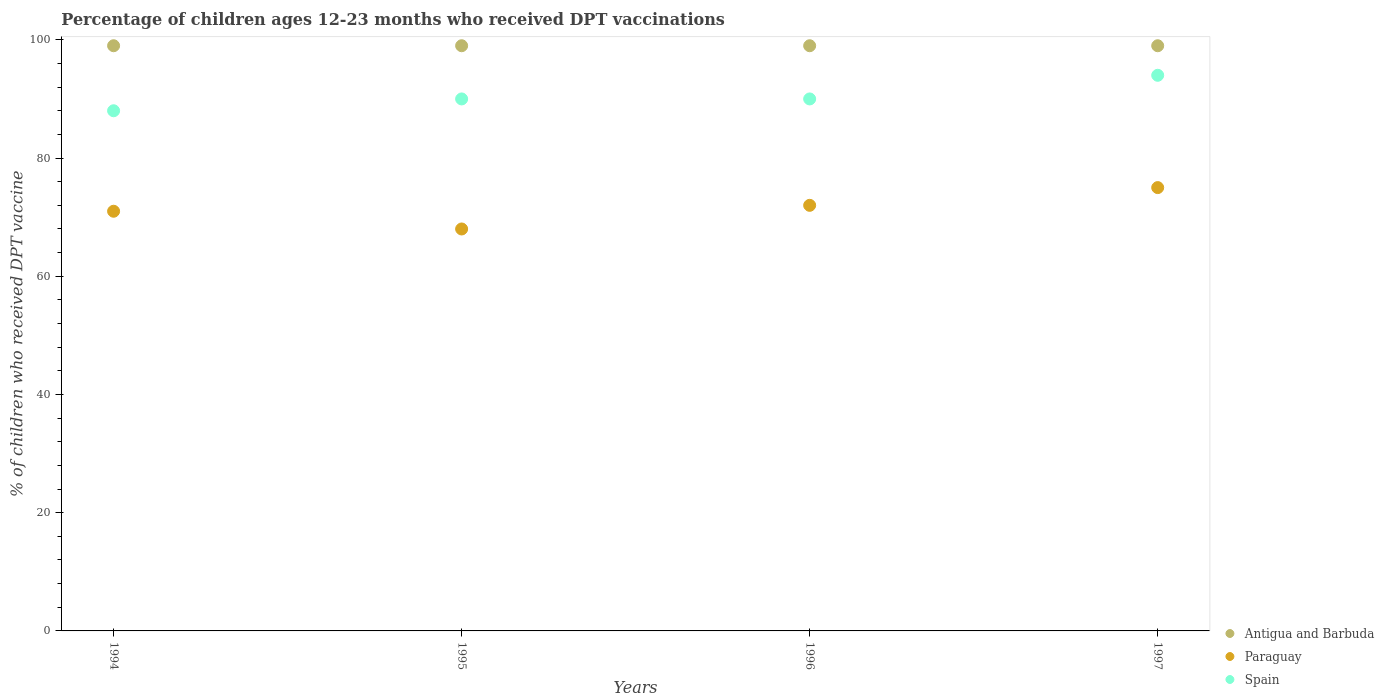How many different coloured dotlines are there?
Give a very brief answer. 3. What is the percentage of children who received DPT vaccination in Antigua and Barbuda in 1996?
Make the answer very short. 99. Across all years, what is the maximum percentage of children who received DPT vaccination in Antigua and Barbuda?
Make the answer very short. 99. Across all years, what is the minimum percentage of children who received DPT vaccination in Antigua and Barbuda?
Your response must be concise. 99. In which year was the percentage of children who received DPT vaccination in Antigua and Barbuda minimum?
Make the answer very short. 1994. What is the total percentage of children who received DPT vaccination in Antigua and Barbuda in the graph?
Your response must be concise. 396. What is the difference between the percentage of children who received DPT vaccination in Paraguay in 1994 and the percentage of children who received DPT vaccination in Antigua and Barbuda in 1996?
Your answer should be very brief. -28. What is the average percentage of children who received DPT vaccination in Antigua and Barbuda per year?
Offer a terse response. 99. In the year 1995, what is the difference between the percentage of children who received DPT vaccination in Antigua and Barbuda and percentage of children who received DPT vaccination in Paraguay?
Offer a very short reply. 31. What is the ratio of the percentage of children who received DPT vaccination in Spain in 1995 to that in 1996?
Give a very brief answer. 1. Is the difference between the percentage of children who received DPT vaccination in Antigua and Barbuda in 1996 and 1997 greater than the difference between the percentage of children who received DPT vaccination in Paraguay in 1996 and 1997?
Provide a succinct answer. Yes. What is the difference between the highest and the lowest percentage of children who received DPT vaccination in Paraguay?
Provide a succinct answer. 7. In how many years, is the percentage of children who received DPT vaccination in Spain greater than the average percentage of children who received DPT vaccination in Spain taken over all years?
Your answer should be compact. 1. Does the percentage of children who received DPT vaccination in Spain monotonically increase over the years?
Offer a very short reply. No. Is the percentage of children who received DPT vaccination in Spain strictly greater than the percentage of children who received DPT vaccination in Antigua and Barbuda over the years?
Your answer should be very brief. No. Is the percentage of children who received DPT vaccination in Spain strictly less than the percentage of children who received DPT vaccination in Paraguay over the years?
Give a very brief answer. No. How many years are there in the graph?
Give a very brief answer. 4. What is the difference between two consecutive major ticks on the Y-axis?
Your answer should be compact. 20. Does the graph contain any zero values?
Provide a succinct answer. No. Does the graph contain grids?
Your response must be concise. No. How many legend labels are there?
Offer a terse response. 3. What is the title of the graph?
Ensure brevity in your answer.  Percentage of children ages 12-23 months who received DPT vaccinations. Does "Turks and Caicos Islands" appear as one of the legend labels in the graph?
Your response must be concise. No. What is the label or title of the Y-axis?
Ensure brevity in your answer.  % of children who received DPT vaccine. What is the % of children who received DPT vaccine in Spain in 1994?
Make the answer very short. 88. What is the % of children who received DPT vaccine of Spain in 1995?
Offer a terse response. 90. What is the % of children who received DPT vaccine in Antigua and Barbuda in 1996?
Give a very brief answer. 99. What is the % of children who received DPT vaccine in Paraguay in 1996?
Make the answer very short. 72. What is the % of children who received DPT vaccine in Spain in 1996?
Your answer should be compact. 90. What is the % of children who received DPT vaccine in Spain in 1997?
Your answer should be compact. 94. Across all years, what is the maximum % of children who received DPT vaccine in Antigua and Barbuda?
Offer a very short reply. 99. Across all years, what is the maximum % of children who received DPT vaccine in Paraguay?
Provide a short and direct response. 75. Across all years, what is the maximum % of children who received DPT vaccine in Spain?
Provide a succinct answer. 94. Across all years, what is the minimum % of children who received DPT vaccine in Paraguay?
Provide a succinct answer. 68. What is the total % of children who received DPT vaccine in Antigua and Barbuda in the graph?
Ensure brevity in your answer.  396. What is the total % of children who received DPT vaccine of Paraguay in the graph?
Your answer should be very brief. 286. What is the total % of children who received DPT vaccine in Spain in the graph?
Offer a very short reply. 362. What is the difference between the % of children who received DPT vaccine of Spain in 1994 and that in 1996?
Your answer should be compact. -2. What is the difference between the % of children who received DPT vaccine in Antigua and Barbuda in 1994 and that in 1997?
Your answer should be compact. 0. What is the difference between the % of children who received DPT vaccine of Spain in 1994 and that in 1997?
Your answer should be compact. -6. What is the difference between the % of children who received DPT vaccine of Antigua and Barbuda in 1995 and that in 1997?
Your response must be concise. 0. What is the difference between the % of children who received DPT vaccine of Spain in 1996 and that in 1997?
Your response must be concise. -4. What is the difference between the % of children who received DPT vaccine in Antigua and Barbuda in 1994 and the % of children who received DPT vaccine in Spain in 1995?
Provide a short and direct response. 9. What is the difference between the % of children who received DPT vaccine of Paraguay in 1994 and the % of children who received DPT vaccine of Spain in 1995?
Your answer should be compact. -19. What is the difference between the % of children who received DPT vaccine in Antigua and Barbuda in 1994 and the % of children who received DPT vaccine in Paraguay in 1997?
Provide a short and direct response. 24. What is the difference between the % of children who received DPT vaccine in Antigua and Barbuda in 1994 and the % of children who received DPT vaccine in Spain in 1997?
Ensure brevity in your answer.  5. What is the difference between the % of children who received DPT vaccine of Paraguay in 1994 and the % of children who received DPT vaccine of Spain in 1997?
Keep it short and to the point. -23. What is the difference between the % of children who received DPT vaccine in Paraguay in 1995 and the % of children who received DPT vaccine in Spain in 1996?
Your answer should be very brief. -22. What is the average % of children who received DPT vaccine of Antigua and Barbuda per year?
Provide a succinct answer. 99. What is the average % of children who received DPT vaccine in Paraguay per year?
Your answer should be very brief. 71.5. What is the average % of children who received DPT vaccine of Spain per year?
Offer a terse response. 90.5. In the year 1995, what is the difference between the % of children who received DPT vaccine in Antigua and Barbuda and % of children who received DPT vaccine in Paraguay?
Offer a terse response. 31. In the year 1997, what is the difference between the % of children who received DPT vaccine of Antigua and Barbuda and % of children who received DPT vaccine of Paraguay?
Your response must be concise. 24. In the year 1997, what is the difference between the % of children who received DPT vaccine of Paraguay and % of children who received DPT vaccine of Spain?
Ensure brevity in your answer.  -19. What is the ratio of the % of children who received DPT vaccine of Paraguay in 1994 to that in 1995?
Offer a very short reply. 1.04. What is the ratio of the % of children who received DPT vaccine in Spain in 1994 to that in 1995?
Offer a terse response. 0.98. What is the ratio of the % of children who received DPT vaccine of Paraguay in 1994 to that in 1996?
Ensure brevity in your answer.  0.99. What is the ratio of the % of children who received DPT vaccine of Spain in 1994 to that in 1996?
Keep it short and to the point. 0.98. What is the ratio of the % of children who received DPT vaccine of Antigua and Barbuda in 1994 to that in 1997?
Your response must be concise. 1. What is the ratio of the % of children who received DPT vaccine of Paraguay in 1994 to that in 1997?
Offer a terse response. 0.95. What is the ratio of the % of children who received DPT vaccine of Spain in 1994 to that in 1997?
Offer a very short reply. 0.94. What is the ratio of the % of children who received DPT vaccine of Antigua and Barbuda in 1995 to that in 1996?
Ensure brevity in your answer.  1. What is the ratio of the % of children who received DPT vaccine of Spain in 1995 to that in 1996?
Offer a terse response. 1. What is the ratio of the % of children who received DPT vaccine of Paraguay in 1995 to that in 1997?
Your answer should be very brief. 0.91. What is the ratio of the % of children who received DPT vaccine of Spain in 1995 to that in 1997?
Ensure brevity in your answer.  0.96. What is the ratio of the % of children who received DPT vaccine in Antigua and Barbuda in 1996 to that in 1997?
Offer a very short reply. 1. What is the ratio of the % of children who received DPT vaccine in Paraguay in 1996 to that in 1997?
Your answer should be very brief. 0.96. What is the ratio of the % of children who received DPT vaccine of Spain in 1996 to that in 1997?
Offer a very short reply. 0.96. What is the difference between the highest and the second highest % of children who received DPT vaccine of Antigua and Barbuda?
Provide a succinct answer. 0. What is the difference between the highest and the second highest % of children who received DPT vaccine in Paraguay?
Make the answer very short. 3. What is the difference between the highest and the second highest % of children who received DPT vaccine of Spain?
Give a very brief answer. 4. What is the difference between the highest and the lowest % of children who received DPT vaccine in Paraguay?
Offer a very short reply. 7. 